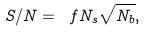Convert formula to latex. <formula><loc_0><loc_0><loc_500><loc_500>S / N = \ f { N _ { s } } { \sqrt { N _ { b } } } ,</formula> 